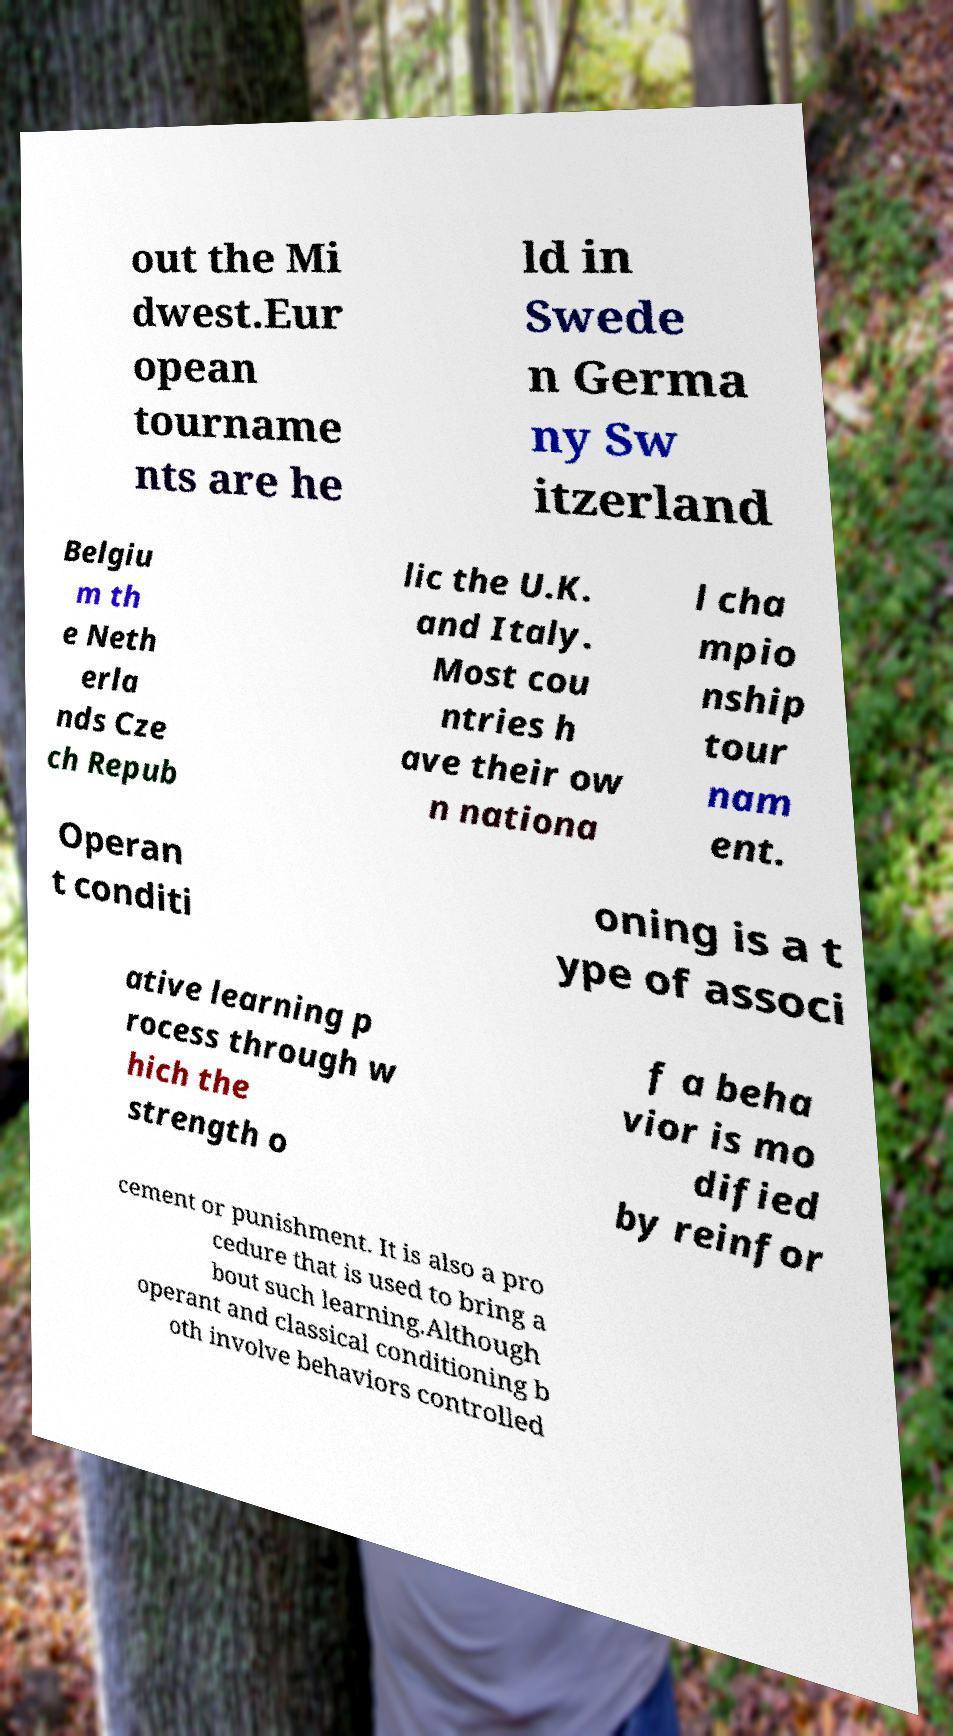Can you read and provide the text displayed in the image?This photo seems to have some interesting text. Can you extract and type it out for me? out the Mi dwest.Eur opean tourname nts are he ld in Swede n Germa ny Sw itzerland Belgiu m th e Neth erla nds Cze ch Repub lic the U.K. and Italy. Most cou ntries h ave their ow n nationa l cha mpio nship tour nam ent. Operan t conditi oning is a t ype of associ ative learning p rocess through w hich the strength o f a beha vior is mo dified by reinfor cement or punishment. It is also a pro cedure that is used to bring a bout such learning.Although operant and classical conditioning b oth involve behaviors controlled 